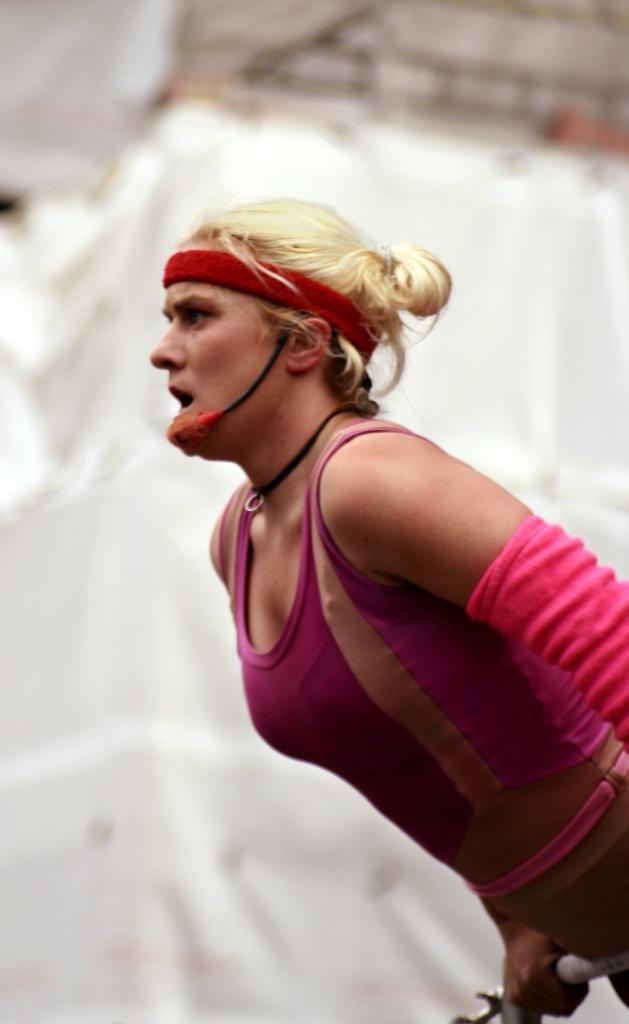Describe this image in one or two sentences. In this picture we can see a woman holding an object with her hand and in the background we can see some objects and it is blurry. 